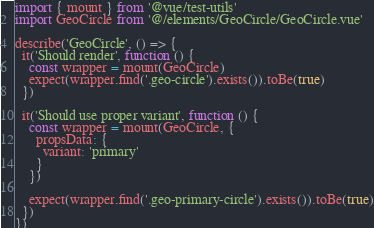<code> <loc_0><loc_0><loc_500><loc_500><_JavaScript_>import { mount } from '@vue/test-utils'
import GeoCircle from '@/elements/GeoCircle/GeoCircle.vue'

describe('GeoCircle', () => {
  it('Should render', function () {
    const wrapper = mount(GeoCircle)
    expect(wrapper.find('.geo-circle').exists()).toBe(true)
  })

  it('Should use proper variant', function () {
    const wrapper = mount(GeoCircle, {
      propsData: {
        variant: 'primary'
      }
    })

    expect(wrapper.find('.geo-primary-circle').exists()).toBe(true)
  })
})
</code> 